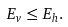Convert formula to latex. <formula><loc_0><loc_0><loc_500><loc_500>E _ { v } \leq E _ { h } .</formula> 